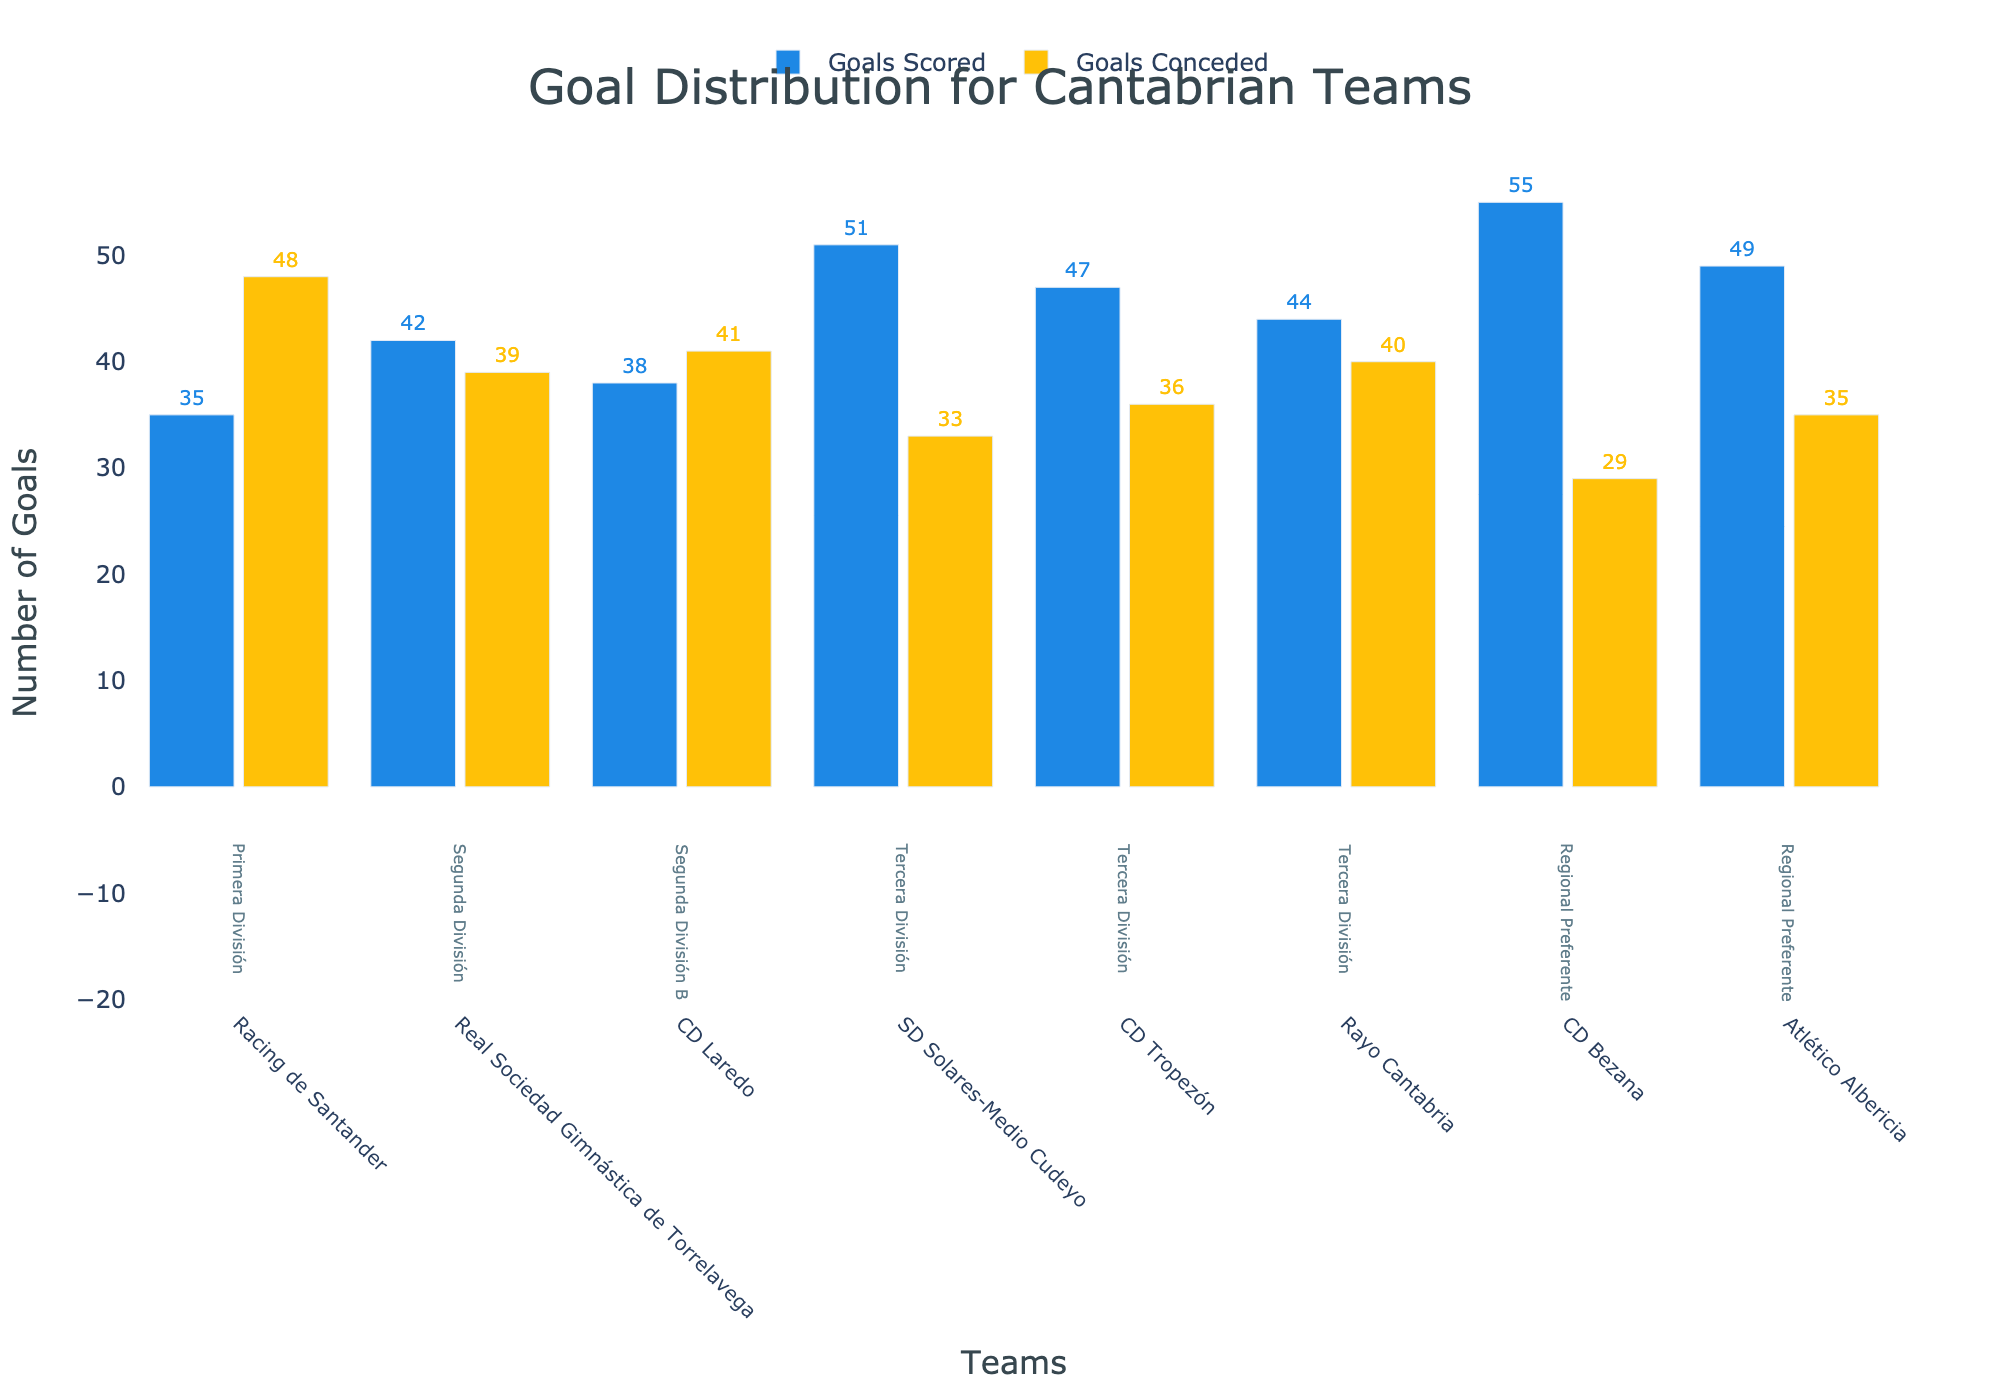What's the title of the plot? The title of the plot is displayed at the top and reads "Goal Distribution for Cantabrian Teams".
Answer: Goal Distribution for Cantabrian Teams Which team in the Regional Preferente has conceded the most goals? Look at the teams in the "Regional Preferente" division and compare the "Goals Conceded" values for each team. CD Bezana has conceded 29 goals, while Atlético Albericia has conceded 35 goals, so Atlético Albericia has conceded the most.
Answer: Atlético Albericia Which team has scored the highest number of goals in Tercera División? Look at the goals scored by the teams in the "Tercera División" division and identify the highest value. SD Solares-Medio Cudeyo has scored 51 goals, which is the highest among the teams in this division.
Answer: SD Solares-Medio Cudeyo How many teams are included in the plot? Count the number of distinct teams listed on the x-axis. There are a total of 8 teams displayed in the plot.
Answer: 8 What is the ratio of goals scored to goals conceded for Real Sociedad Gimnástica de Torrelavega? Real Sociedad Gimnástica de Torrelavega has scored 42 goals and conceded 39 goals. The ratio is calculated as Goals Scored divided by Goals Conceded: 42 ÷ 39.
Answer: 1.08 Which team has the largest goal difference (Goals Scored - Goals Conceded) and what is the value? Calculate the goal difference for each team and identify the largest. For example, for CD Bezana in the Regional Preferente, the goal difference is 55 - 29 = 26. Repeat for all teams to find the team with the largest difference, which is CD Bezana with a difference of 26.
Answer: CD Bezana, 26 Compare the total goals scored by all teams in Tercera División to those in Regional Preferente. Which division has more? Sum the goals scored by the three teams in Tercera División (51 + 47 + 44 = 142) and the two teams in Regional Preferente (55 + 49 = 104). Tercera División has more goals scored in total.
Answer: Tercera División Which division in the plot is represented by the most number of teams? Identify the division category mentioned most frequently under the team names in the annotations. Tercera División is represented by three teams (SD Solares-Medio Cudeyo, CD Tropezón, Rayo Cantabria).
Answer: Tercera División What is the combined goals conceded by the teams in Segunda División? Look at the "Goals Conceded" values for the teams in Segunda División and sum them up. Real Sociedad Gimnástica de Torrelavega has conceded 39 goals. There's only one team in Segunda División, so the total is 39.
Answer: 39 